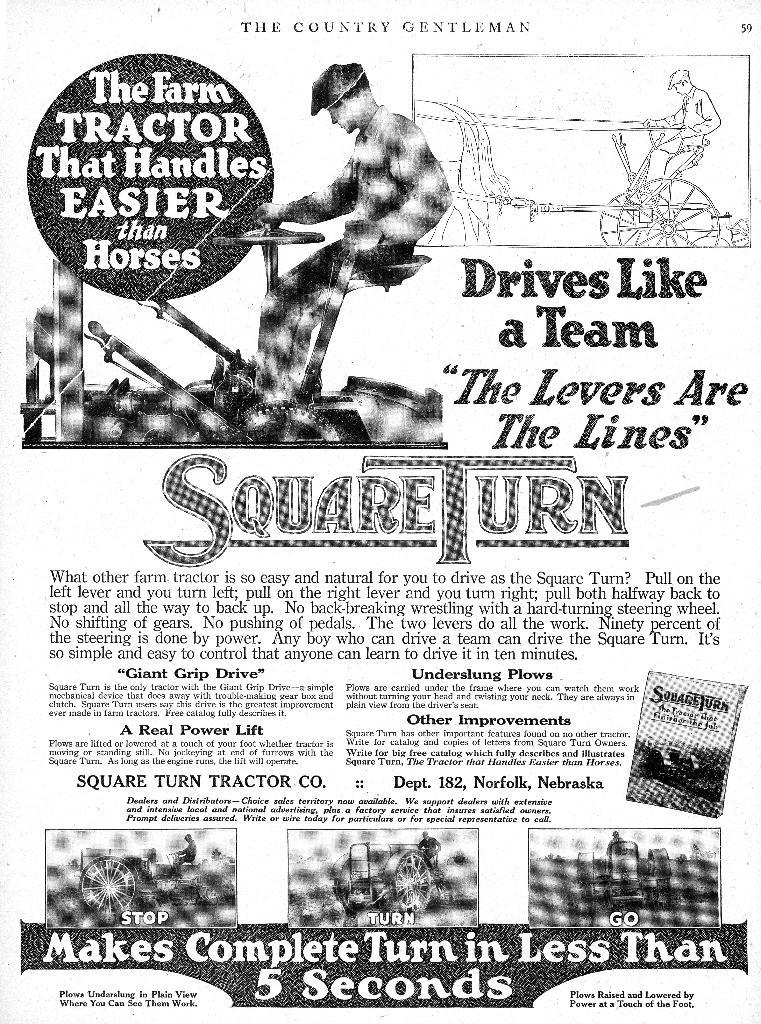What is featured on the poster in the image? There is a poster in the image, and it contains a picture of a man. What else is present on the poster besides the picture of the man? There is text on the poster. What time does the clock show in the image? There is no clock present in the image. What type of food is the cook preparing in the image? There is no cook or food preparation visible in the image. Is there a bath or bathtub present in the image? There is no bath or bathtub present in the image. 